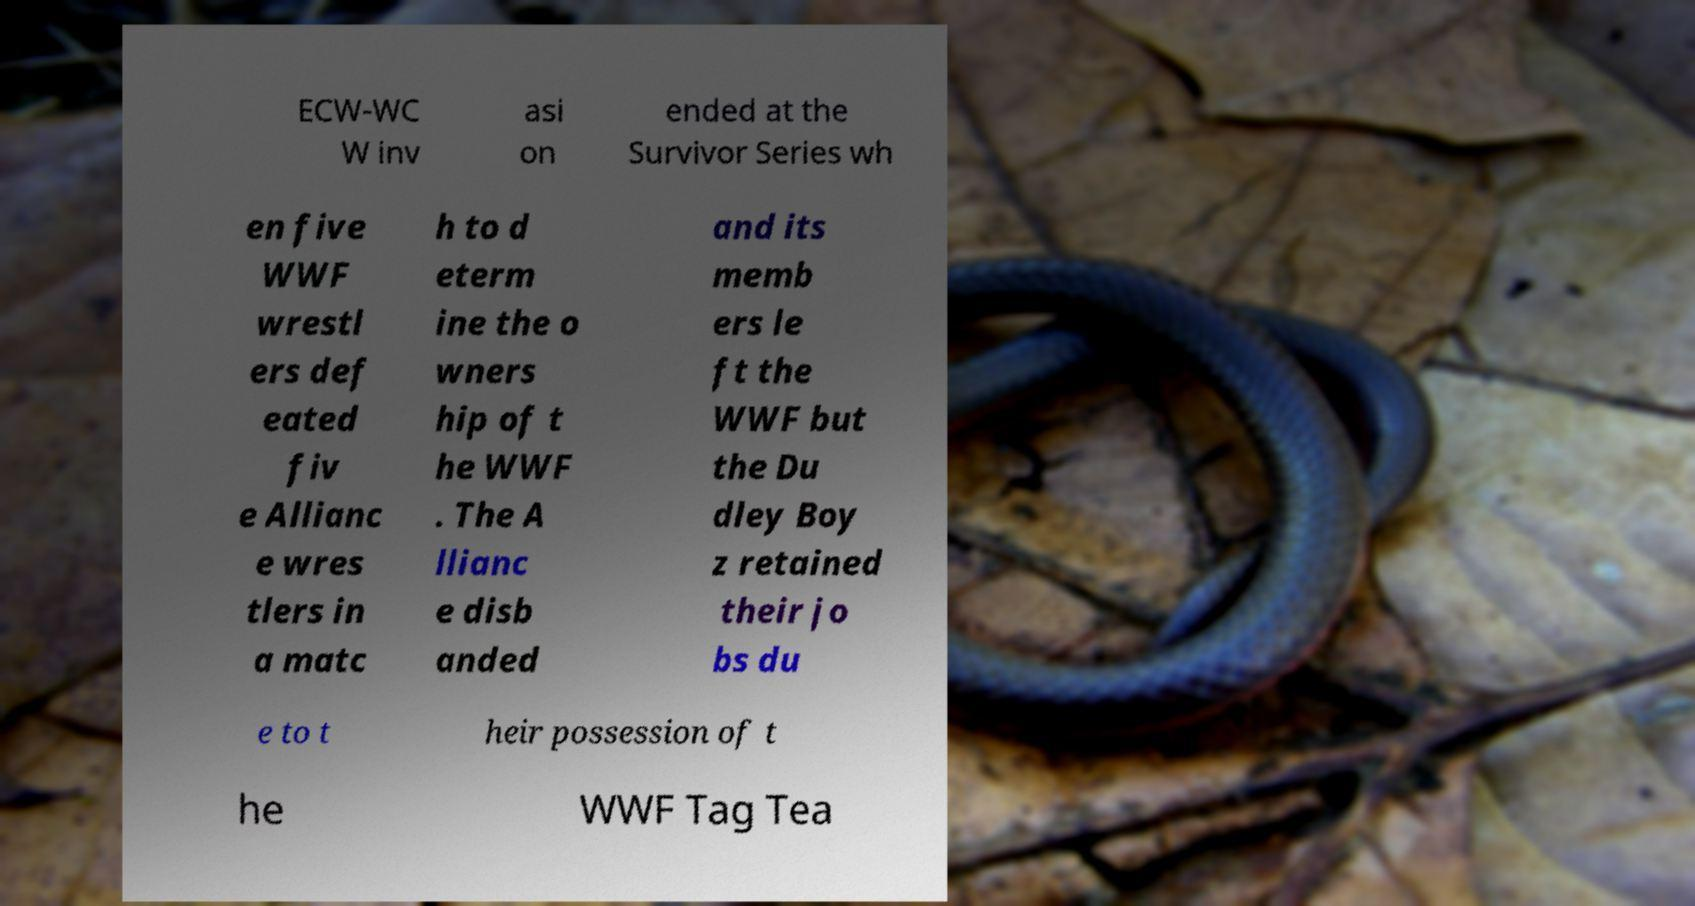Could you extract and type out the text from this image? ECW-WC W inv asi on ended at the Survivor Series wh en five WWF wrestl ers def eated fiv e Allianc e wres tlers in a matc h to d eterm ine the o wners hip of t he WWF . The A llianc e disb anded and its memb ers le ft the WWF but the Du dley Boy z retained their jo bs du e to t heir possession of t he WWF Tag Tea 